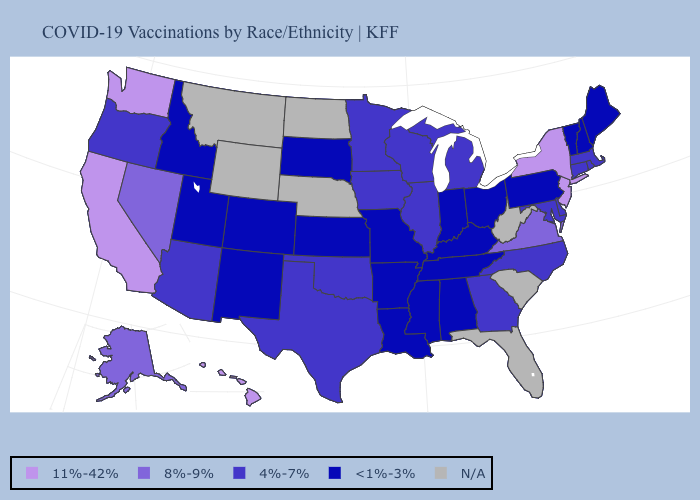Name the states that have a value in the range 4%-7%?
Answer briefly. Arizona, Connecticut, Delaware, Georgia, Illinois, Iowa, Maryland, Massachusetts, Michigan, Minnesota, North Carolina, Oklahoma, Oregon, Rhode Island, Texas, Wisconsin. What is the highest value in the MidWest ?
Short answer required. 4%-7%. Name the states that have a value in the range N/A?
Answer briefly. Florida, Montana, Nebraska, North Dakota, South Carolina, West Virginia, Wyoming. What is the value of Montana?
Keep it brief. N/A. What is the highest value in states that border Wyoming?
Keep it brief. <1%-3%. Is the legend a continuous bar?
Answer briefly. No. What is the highest value in the MidWest ?
Be succinct. 4%-7%. Name the states that have a value in the range N/A?
Answer briefly. Florida, Montana, Nebraska, North Dakota, South Carolina, West Virginia, Wyoming. What is the lowest value in the South?
Be succinct. <1%-3%. Is the legend a continuous bar?
Keep it brief. No. What is the value of Hawaii?
Quick response, please. 11%-42%. Does the map have missing data?
Short answer required. Yes. What is the value of Oregon?
Keep it brief. 4%-7%. 